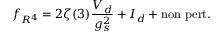<formula> <loc_0><loc_0><loc_500><loc_500>f _ { R ^ { 4 } } = 2 \zeta ( 3 ) \frac { V _ { d } } { g _ { s } ^ { 2 } } + I _ { d } + n o n p e r t .</formula> 